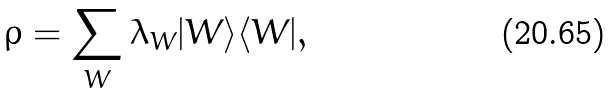<formula> <loc_0><loc_0><loc_500><loc_500>\rho = \sum _ { W } \lambda _ { W } | W \rangle \langle W | ,</formula> 